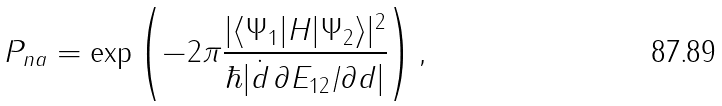<formula> <loc_0><loc_0><loc_500><loc_500>P _ { n a } = \exp \left ( - 2 \pi \frac { | \langle \Psi _ { 1 } | { H } | \Psi _ { 2 } \rangle | ^ { 2 } } { \hbar { | } \dot { d } \, \partial E _ { 1 2 } / \partial d | } \right ) ,</formula> 